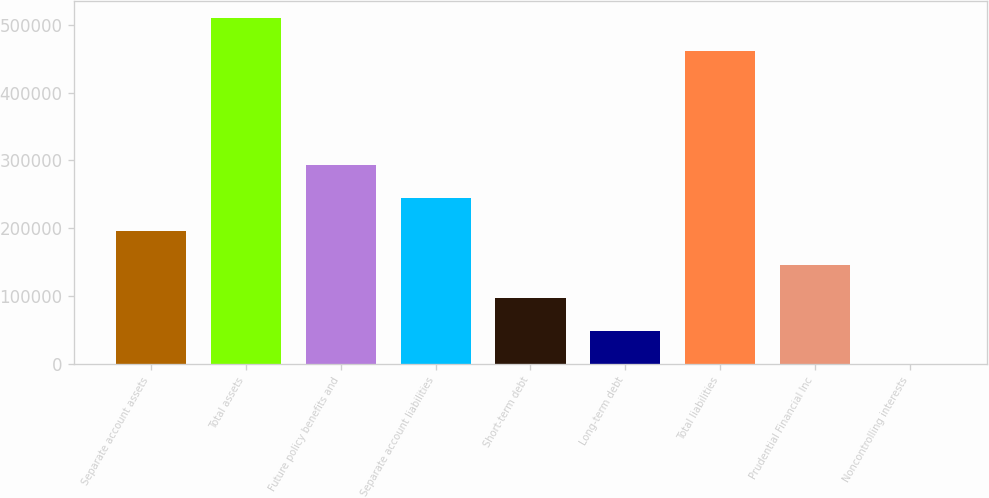Convert chart to OTSL. <chart><loc_0><loc_0><loc_500><loc_500><bar_chart><fcel>Separate account assets<fcel>Total assets<fcel>Future policy benefits and<fcel>Separate account liabilities<fcel>Short-term debt<fcel>Long-term debt<fcel>Total liabilities<fcel>Prudential Financial Inc<fcel>Noncontrolling interests<nl><fcel>195583<fcel>510430<fcel>292664<fcel>244123<fcel>97489.8<fcel>48949.4<fcel>461890<fcel>146030<fcel>409<nl></chart> 